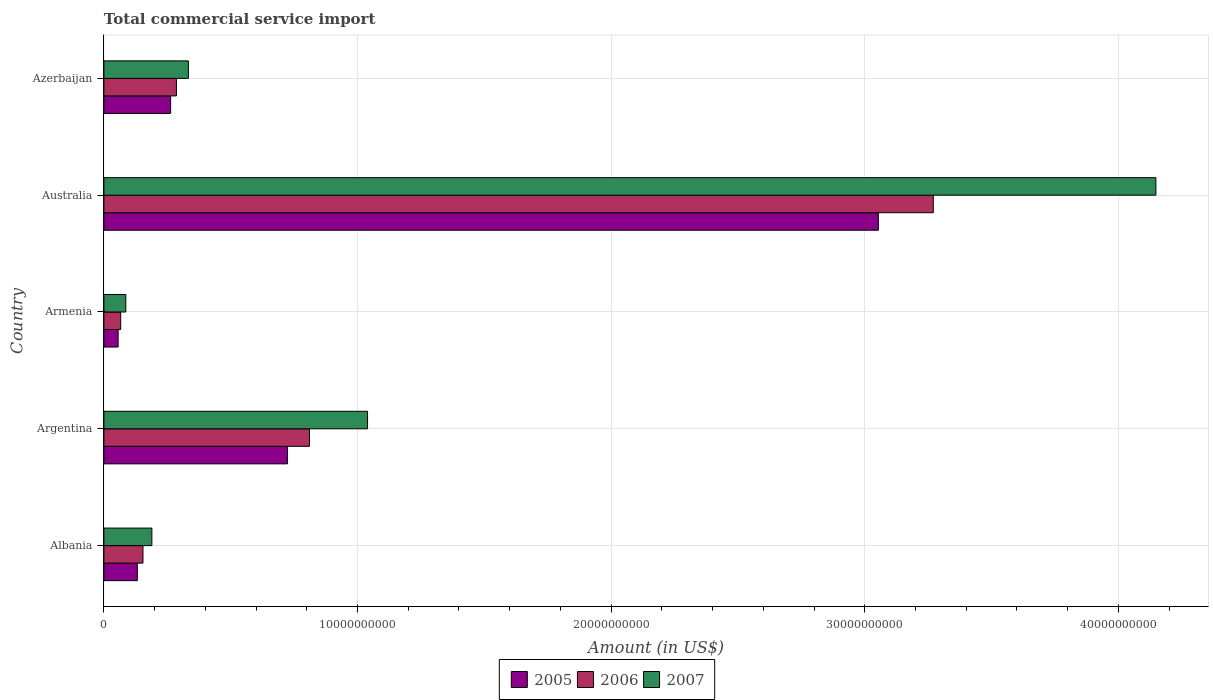How many groups of bars are there?
Ensure brevity in your answer.  5. Are the number of bars per tick equal to the number of legend labels?
Your answer should be very brief. Yes. Are the number of bars on each tick of the Y-axis equal?
Provide a short and direct response. Yes. What is the label of the 1st group of bars from the top?
Offer a terse response. Azerbaijan. What is the total commercial service import in 2006 in Azerbaijan?
Offer a terse response. 2.86e+09. Across all countries, what is the maximum total commercial service import in 2005?
Your answer should be very brief. 3.05e+1. Across all countries, what is the minimum total commercial service import in 2006?
Ensure brevity in your answer.  6.62e+08. In which country was the total commercial service import in 2005 maximum?
Give a very brief answer. Australia. In which country was the total commercial service import in 2006 minimum?
Keep it short and to the point. Armenia. What is the total total commercial service import in 2007 in the graph?
Ensure brevity in your answer.  5.80e+1. What is the difference between the total commercial service import in 2005 in Armenia and that in Azerbaijan?
Your answer should be very brief. -2.07e+09. What is the difference between the total commercial service import in 2005 in Argentina and the total commercial service import in 2007 in Australia?
Your response must be concise. -3.42e+1. What is the average total commercial service import in 2007 per country?
Give a very brief answer. 1.16e+1. What is the difference between the total commercial service import in 2007 and total commercial service import in 2006 in Argentina?
Offer a terse response. 2.29e+09. In how many countries, is the total commercial service import in 2005 greater than 18000000000 US$?
Keep it short and to the point. 1. What is the ratio of the total commercial service import in 2006 in Albania to that in Australia?
Keep it short and to the point. 0.05. Is the total commercial service import in 2007 in Albania less than that in Argentina?
Ensure brevity in your answer.  Yes. What is the difference between the highest and the second highest total commercial service import in 2007?
Offer a very short reply. 3.11e+1. What is the difference between the highest and the lowest total commercial service import in 2005?
Make the answer very short. 3.00e+1. In how many countries, is the total commercial service import in 2007 greater than the average total commercial service import in 2007 taken over all countries?
Your answer should be compact. 1. Is it the case that in every country, the sum of the total commercial service import in 2005 and total commercial service import in 2007 is greater than the total commercial service import in 2006?
Provide a short and direct response. Yes. Are all the bars in the graph horizontal?
Your answer should be compact. Yes. How many countries are there in the graph?
Your answer should be compact. 5. Are the values on the major ticks of X-axis written in scientific E-notation?
Your answer should be very brief. No. Where does the legend appear in the graph?
Offer a very short reply. Bottom center. How many legend labels are there?
Your response must be concise. 3. What is the title of the graph?
Offer a terse response. Total commercial service import. What is the label or title of the Y-axis?
Provide a succinct answer. Country. What is the Amount (in US$) in 2005 in Albania?
Keep it short and to the point. 1.32e+09. What is the Amount (in US$) in 2006 in Albania?
Your answer should be very brief. 1.54e+09. What is the Amount (in US$) in 2007 in Albania?
Your answer should be compact. 1.89e+09. What is the Amount (in US$) of 2005 in Argentina?
Your answer should be very brief. 7.24e+09. What is the Amount (in US$) in 2006 in Argentina?
Offer a terse response. 8.10e+09. What is the Amount (in US$) in 2007 in Argentina?
Your answer should be compact. 1.04e+1. What is the Amount (in US$) of 2005 in Armenia?
Offer a very short reply. 5.61e+08. What is the Amount (in US$) of 2006 in Armenia?
Give a very brief answer. 6.62e+08. What is the Amount (in US$) in 2007 in Armenia?
Your answer should be compact. 8.64e+08. What is the Amount (in US$) of 2005 in Australia?
Offer a very short reply. 3.05e+1. What is the Amount (in US$) of 2006 in Australia?
Keep it short and to the point. 3.27e+1. What is the Amount (in US$) in 2007 in Australia?
Offer a very short reply. 4.15e+1. What is the Amount (in US$) in 2005 in Azerbaijan?
Provide a succinct answer. 2.63e+09. What is the Amount (in US$) of 2006 in Azerbaijan?
Your answer should be very brief. 2.86e+09. What is the Amount (in US$) of 2007 in Azerbaijan?
Provide a short and direct response. 3.33e+09. Across all countries, what is the maximum Amount (in US$) of 2005?
Ensure brevity in your answer.  3.05e+1. Across all countries, what is the maximum Amount (in US$) in 2006?
Offer a very short reply. 3.27e+1. Across all countries, what is the maximum Amount (in US$) in 2007?
Your answer should be very brief. 4.15e+1. Across all countries, what is the minimum Amount (in US$) in 2005?
Offer a very short reply. 5.61e+08. Across all countries, what is the minimum Amount (in US$) of 2006?
Make the answer very short. 6.62e+08. Across all countries, what is the minimum Amount (in US$) in 2007?
Your answer should be compact. 8.64e+08. What is the total Amount (in US$) of 2005 in the graph?
Keep it short and to the point. 4.23e+1. What is the total Amount (in US$) in 2006 in the graph?
Provide a succinct answer. 4.59e+1. What is the total Amount (in US$) in 2007 in the graph?
Your answer should be very brief. 5.80e+1. What is the difference between the Amount (in US$) of 2005 in Albania and that in Argentina?
Your answer should be very brief. -5.92e+09. What is the difference between the Amount (in US$) of 2006 in Albania and that in Argentina?
Give a very brief answer. -6.56e+09. What is the difference between the Amount (in US$) in 2007 in Albania and that in Argentina?
Keep it short and to the point. -8.50e+09. What is the difference between the Amount (in US$) of 2005 in Albania and that in Armenia?
Provide a succinct answer. 7.56e+08. What is the difference between the Amount (in US$) in 2006 in Albania and that in Armenia?
Offer a terse response. 8.79e+08. What is the difference between the Amount (in US$) in 2007 in Albania and that in Armenia?
Offer a very short reply. 1.03e+09. What is the difference between the Amount (in US$) in 2005 in Albania and that in Australia?
Give a very brief answer. -2.92e+1. What is the difference between the Amount (in US$) in 2006 in Albania and that in Australia?
Provide a short and direct response. -3.12e+1. What is the difference between the Amount (in US$) in 2007 in Albania and that in Australia?
Your answer should be very brief. -3.96e+1. What is the difference between the Amount (in US$) in 2005 in Albania and that in Azerbaijan?
Offer a very short reply. -1.31e+09. What is the difference between the Amount (in US$) of 2006 in Albania and that in Azerbaijan?
Offer a terse response. -1.32e+09. What is the difference between the Amount (in US$) of 2007 in Albania and that in Azerbaijan?
Offer a terse response. -1.44e+09. What is the difference between the Amount (in US$) of 2005 in Argentina and that in Armenia?
Your answer should be very brief. 6.67e+09. What is the difference between the Amount (in US$) of 2006 in Argentina and that in Armenia?
Keep it short and to the point. 7.44e+09. What is the difference between the Amount (in US$) of 2007 in Argentina and that in Armenia?
Make the answer very short. 9.53e+09. What is the difference between the Amount (in US$) in 2005 in Argentina and that in Australia?
Your answer should be very brief. -2.33e+1. What is the difference between the Amount (in US$) of 2006 in Argentina and that in Australia?
Your answer should be very brief. -2.46e+1. What is the difference between the Amount (in US$) in 2007 in Argentina and that in Australia?
Give a very brief answer. -3.11e+1. What is the difference between the Amount (in US$) of 2005 in Argentina and that in Azerbaijan?
Your response must be concise. 4.60e+09. What is the difference between the Amount (in US$) of 2006 in Argentina and that in Azerbaijan?
Keep it short and to the point. 5.25e+09. What is the difference between the Amount (in US$) in 2007 in Argentina and that in Azerbaijan?
Provide a short and direct response. 7.06e+09. What is the difference between the Amount (in US$) of 2005 in Armenia and that in Australia?
Your response must be concise. -3.00e+1. What is the difference between the Amount (in US$) of 2006 in Armenia and that in Australia?
Your response must be concise. -3.20e+1. What is the difference between the Amount (in US$) of 2007 in Armenia and that in Australia?
Your answer should be compact. -4.06e+1. What is the difference between the Amount (in US$) of 2005 in Armenia and that in Azerbaijan?
Keep it short and to the point. -2.07e+09. What is the difference between the Amount (in US$) of 2006 in Armenia and that in Azerbaijan?
Give a very brief answer. -2.20e+09. What is the difference between the Amount (in US$) of 2007 in Armenia and that in Azerbaijan?
Provide a short and direct response. -2.47e+09. What is the difference between the Amount (in US$) of 2005 in Australia and that in Azerbaijan?
Offer a terse response. 2.79e+1. What is the difference between the Amount (in US$) in 2006 in Australia and that in Azerbaijan?
Give a very brief answer. 2.98e+1. What is the difference between the Amount (in US$) of 2007 in Australia and that in Azerbaijan?
Your answer should be very brief. 3.81e+1. What is the difference between the Amount (in US$) in 2005 in Albania and the Amount (in US$) in 2006 in Argentina?
Make the answer very short. -6.79e+09. What is the difference between the Amount (in US$) of 2005 in Albania and the Amount (in US$) of 2007 in Argentina?
Provide a short and direct response. -9.08e+09. What is the difference between the Amount (in US$) of 2006 in Albania and the Amount (in US$) of 2007 in Argentina?
Offer a terse response. -8.85e+09. What is the difference between the Amount (in US$) of 2005 in Albania and the Amount (in US$) of 2006 in Armenia?
Ensure brevity in your answer.  6.55e+08. What is the difference between the Amount (in US$) in 2005 in Albania and the Amount (in US$) in 2007 in Armenia?
Offer a very short reply. 4.53e+08. What is the difference between the Amount (in US$) of 2006 in Albania and the Amount (in US$) of 2007 in Armenia?
Provide a short and direct response. 6.76e+08. What is the difference between the Amount (in US$) of 2005 in Albania and the Amount (in US$) of 2006 in Australia?
Make the answer very short. -3.14e+1. What is the difference between the Amount (in US$) in 2005 in Albania and the Amount (in US$) in 2007 in Australia?
Your answer should be compact. -4.02e+1. What is the difference between the Amount (in US$) in 2006 in Albania and the Amount (in US$) in 2007 in Australia?
Provide a succinct answer. -3.99e+1. What is the difference between the Amount (in US$) in 2005 in Albania and the Amount (in US$) in 2006 in Azerbaijan?
Provide a succinct answer. -1.54e+09. What is the difference between the Amount (in US$) of 2005 in Albania and the Amount (in US$) of 2007 in Azerbaijan?
Offer a terse response. -2.01e+09. What is the difference between the Amount (in US$) of 2006 in Albania and the Amount (in US$) of 2007 in Azerbaijan?
Your response must be concise. -1.79e+09. What is the difference between the Amount (in US$) of 2005 in Argentina and the Amount (in US$) of 2006 in Armenia?
Keep it short and to the point. 6.57e+09. What is the difference between the Amount (in US$) in 2005 in Argentina and the Amount (in US$) in 2007 in Armenia?
Your response must be concise. 6.37e+09. What is the difference between the Amount (in US$) in 2006 in Argentina and the Amount (in US$) in 2007 in Armenia?
Your answer should be very brief. 7.24e+09. What is the difference between the Amount (in US$) of 2005 in Argentina and the Amount (in US$) of 2006 in Australia?
Provide a short and direct response. -2.55e+1. What is the difference between the Amount (in US$) in 2005 in Argentina and the Amount (in US$) in 2007 in Australia?
Provide a short and direct response. -3.42e+1. What is the difference between the Amount (in US$) of 2006 in Argentina and the Amount (in US$) of 2007 in Australia?
Ensure brevity in your answer.  -3.34e+1. What is the difference between the Amount (in US$) of 2005 in Argentina and the Amount (in US$) of 2006 in Azerbaijan?
Ensure brevity in your answer.  4.38e+09. What is the difference between the Amount (in US$) of 2005 in Argentina and the Amount (in US$) of 2007 in Azerbaijan?
Your answer should be very brief. 3.90e+09. What is the difference between the Amount (in US$) in 2006 in Argentina and the Amount (in US$) in 2007 in Azerbaijan?
Provide a short and direct response. 4.77e+09. What is the difference between the Amount (in US$) of 2005 in Armenia and the Amount (in US$) of 2006 in Australia?
Your answer should be compact. -3.21e+1. What is the difference between the Amount (in US$) of 2005 in Armenia and the Amount (in US$) of 2007 in Australia?
Ensure brevity in your answer.  -4.09e+1. What is the difference between the Amount (in US$) of 2006 in Armenia and the Amount (in US$) of 2007 in Australia?
Keep it short and to the point. -4.08e+1. What is the difference between the Amount (in US$) in 2005 in Armenia and the Amount (in US$) in 2006 in Azerbaijan?
Offer a very short reply. -2.30e+09. What is the difference between the Amount (in US$) in 2005 in Armenia and the Amount (in US$) in 2007 in Azerbaijan?
Give a very brief answer. -2.77e+09. What is the difference between the Amount (in US$) of 2006 in Armenia and the Amount (in US$) of 2007 in Azerbaijan?
Keep it short and to the point. -2.67e+09. What is the difference between the Amount (in US$) in 2005 in Australia and the Amount (in US$) in 2006 in Azerbaijan?
Provide a short and direct response. 2.77e+1. What is the difference between the Amount (in US$) of 2005 in Australia and the Amount (in US$) of 2007 in Azerbaijan?
Your answer should be very brief. 2.72e+1. What is the difference between the Amount (in US$) in 2006 in Australia and the Amount (in US$) in 2007 in Azerbaijan?
Give a very brief answer. 2.94e+1. What is the average Amount (in US$) in 2005 per country?
Make the answer very short. 8.46e+09. What is the average Amount (in US$) in 2006 per country?
Your answer should be compact. 9.17e+09. What is the average Amount (in US$) in 2007 per country?
Your answer should be very brief. 1.16e+1. What is the difference between the Amount (in US$) in 2005 and Amount (in US$) in 2006 in Albania?
Make the answer very short. -2.23e+08. What is the difference between the Amount (in US$) in 2005 and Amount (in US$) in 2007 in Albania?
Give a very brief answer. -5.74e+08. What is the difference between the Amount (in US$) in 2006 and Amount (in US$) in 2007 in Albania?
Your answer should be very brief. -3.51e+08. What is the difference between the Amount (in US$) in 2005 and Amount (in US$) in 2006 in Argentina?
Make the answer very short. -8.69e+08. What is the difference between the Amount (in US$) of 2005 and Amount (in US$) of 2007 in Argentina?
Ensure brevity in your answer.  -3.16e+09. What is the difference between the Amount (in US$) of 2006 and Amount (in US$) of 2007 in Argentina?
Offer a terse response. -2.29e+09. What is the difference between the Amount (in US$) of 2005 and Amount (in US$) of 2006 in Armenia?
Ensure brevity in your answer.  -1.01e+08. What is the difference between the Amount (in US$) of 2005 and Amount (in US$) of 2007 in Armenia?
Keep it short and to the point. -3.03e+08. What is the difference between the Amount (in US$) in 2006 and Amount (in US$) in 2007 in Armenia?
Provide a short and direct response. -2.02e+08. What is the difference between the Amount (in US$) in 2005 and Amount (in US$) in 2006 in Australia?
Ensure brevity in your answer.  -2.17e+09. What is the difference between the Amount (in US$) in 2005 and Amount (in US$) in 2007 in Australia?
Keep it short and to the point. -1.09e+1. What is the difference between the Amount (in US$) of 2006 and Amount (in US$) of 2007 in Australia?
Make the answer very short. -8.78e+09. What is the difference between the Amount (in US$) in 2005 and Amount (in US$) in 2006 in Azerbaijan?
Ensure brevity in your answer.  -2.28e+08. What is the difference between the Amount (in US$) in 2005 and Amount (in US$) in 2007 in Azerbaijan?
Offer a very short reply. -7.00e+08. What is the difference between the Amount (in US$) of 2006 and Amount (in US$) of 2007 in Azerbaijan?
Ensure brevity in your answer.  -4.72e+08. What is the ratio of the Amount (in US$) in 2005 in Albania to that in Argentina?
Provide a succinct answer. 0.18. What is the ratio of the Amount (in US$) of 2006 in Albania to that in Argentina?
Give a very brief answer. 0.19. What is the ratio of the Amount (in US$) in 2007 in Albania to that in Argentina?
Offer a terse response. 0.18. What is the ratio of the Amount (in US$) of 2005 in Albania to that in Armenia?
Offer a very short reply. 2.35. What is the ratio of the Amount (in US$) in 2006 in Albania to that in Armenia?
Provide a succinct answer. 2.33. What is the ratio of the Amount (in US$) of 2007 in Albania to that in Armenia?
Offer a terse response. 2.19. What is the ratio of the Amount (in US$) in 2005 in Albania to that in Australia?
Your answer should be very brief. 0.04. What is the ratio of the Amount (in US$) of 2006 in Albania to that in Australia?
Offer a very short reply. 0.05. What is the ratio of the Amount (in US$) in 2007 in Albania to that in Australia?
Your response must be concise. 0.05. What is the ratio of the Amount (in US$) of 2005 in Albania to that in Azerbaijan?
Your response must be concise. 0.5. What is the ratio of the Amount (in US$) in 2006 in Albania to that in Azerbaijan?
Make the answer very short. 0.54. What is the ratio of the Amount (in US$) of 2007 in Albania to that in Azerbaijan?
Your answer should be very brief. 0.57. What is the ratio of the Amount (in US$) in 2005 in Argentina to that in Armenia?
Provide a succinct answer. 12.89. What is the ratio of the Amount (in US$) in 2006 in Argentina to that in Armenia?
Your response must be concise. 12.24. What is the ratio of the Amount (in US$) in 2007 in Argentina to that in Armenia?
Offer a very short reply. 12.03. What is the ratio of the Amount (in US$) in 2005 in Argentina to that in Australia?
Give a very brief answer. 0.24. What is the ratio of the Amount (in US$) of 2006 in Argentina to that in Australia?
Offer a terse response. 0.25. What is the ratio of the Amount (in US$) in 2007 in Argentina to that in Australia?
Ensure brevity in your answer.  0.25. What is the ratio of the Amount (in US$) in 2005 in Argentina to that in Azerbaijan?
Provide a succinct answer. 2.75. What is the ratio of the Amount (in US$) in 2006 in Argentina to that in Azerbaijan?
Your answer should be very brief. 2.83. What is the ratio of the Amount (in US$) in 2007 in Argentina to that in Azerbaijan?
Provide a short and direct response. 3.12. What is the ratio of the Amount (in US$) in 2005 in Armenia to that in Australia?
Offer a terse response. 0.02. What is the ratio of the Amount (in US$) in 2006 in Armenia to that in Australia?
Your answer should be compact. 0.02. What is the ratio of the Amount (in US$) of 2007 in Armenia to that in Australia?
Your response must be concise. 0.02. What is the ratio of the Amount (in US$) of 2005 in Armenia to that in Azerbaijan?
Keep it short and to the point. 0.21. What is the ratio of the Amount (in US$) of 2006 in Armenia to that in Azerbaijan?
Ensure brevity in your answer.  0.23. What is the ratio of the Amount (in US$) in 2007 in Armenia to that in Azerbaijan?
Keep it short and to the point. 0.26. What is the ratio of the Amount (in US$) of 2005 in Australia to that in Azerbaijan?
Offer a terse response. 11.61. What is the ratio of the Amount (in US$) in 2006 in Australia to that in Azerbaijan?
Provide a short and direct response. 11.44. What is the ratio of the Amount (in US$) in 2007 in Australia to that in Azerbaijan?
Offer a very short reply. 12.45. What is the difference between the highest and the second highest Amount (in US$) of 2005?
Ensure brevity in your answer.  2.33e+1. What is the difference between the highest and the second highest Amount (in US$) of 2006?
Give a very brief answer. 2.46e+1. What is the difference between the highest and the second highest Amount (in US$) in 2007?
Keep it short and to the point. 3.11e+1. What is the difference between the highest and the lowest Amount (in US$) in 2005?
Provide a short and direct response. 3.00e+1. What is the difference between the highest and the lowest Amount (in US$) of 2006?
Offer a terse response. 3.20e+1. What is the difference between the highest and the lowest Amount (in US$) in 2007?
Your response must be concise. 4.06e+1. 